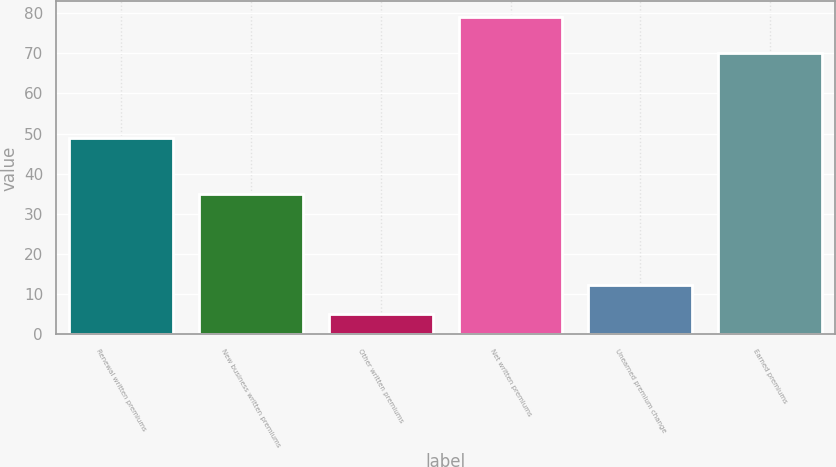<chart> <loc_0><loc_0><loc_500><loc_500><bar_chart><fcel>Renewal written premiums<fcel>New business written premiums<fcel>Other written premiums<fcel>Net written premiums<fcel>Unearned premium change<fcel>Earned premiums<nl><fcel>49<fcel>35<fcel>5<fcel>79<fcel>12.4<fcel>70<nl></chart> 